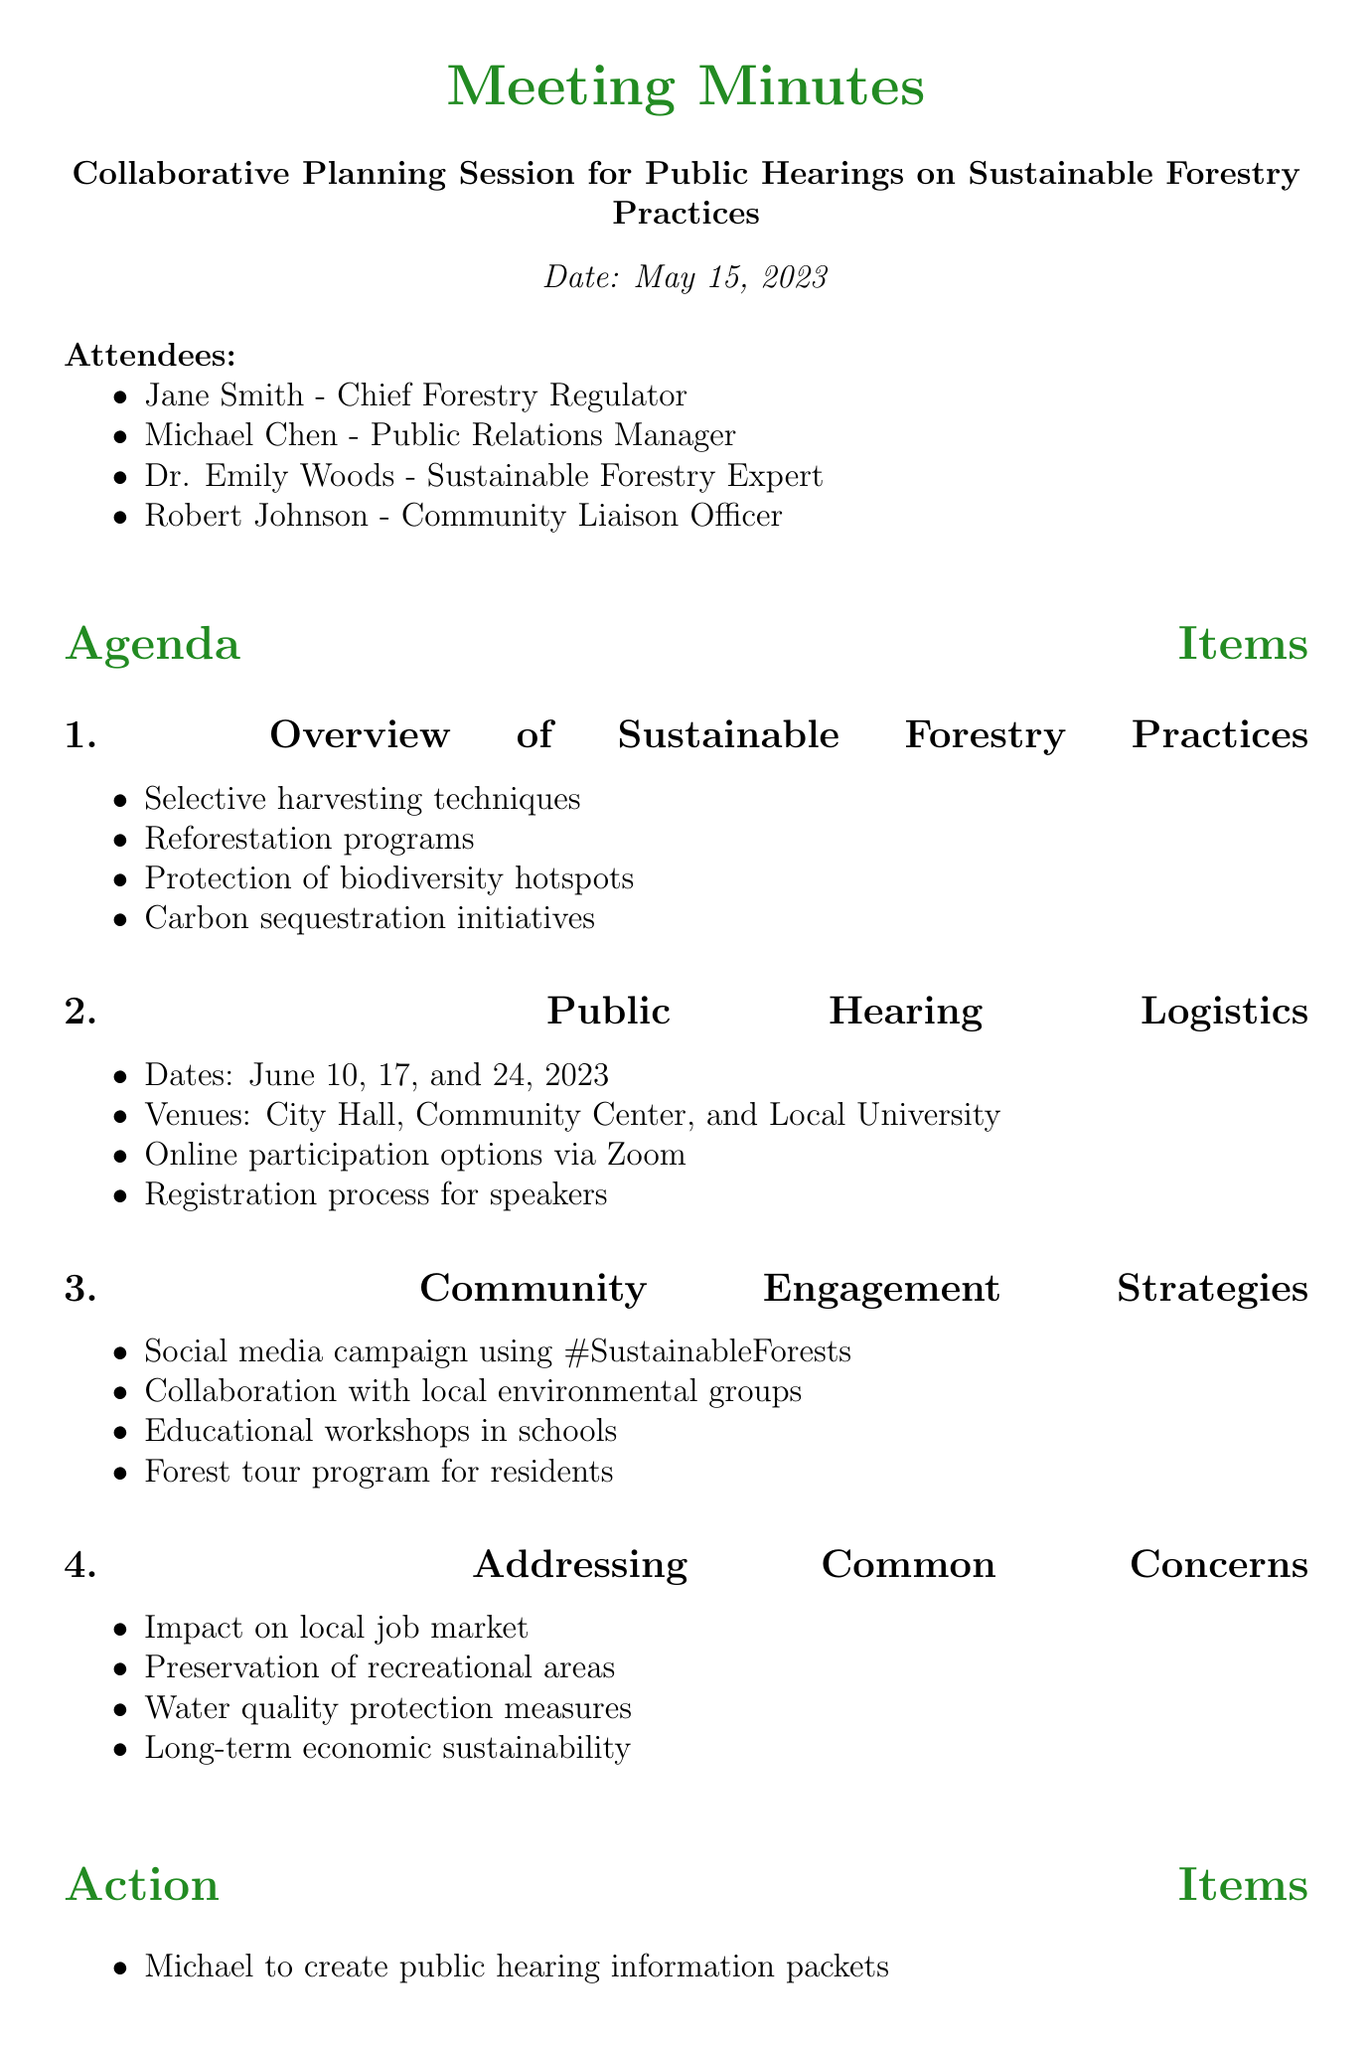What is the meeting title? The meeting title is clearly stated at the top of the document.
Answer: Collaborative Planning Session for Public Hearings on Sustainable Forestry Practices Who is the Chief Forestry Regulator? The document lists attendees along with their titles, making it easy to find who holds which position.
Answer: Jane Smith What are the dates for the public hearings? The specific dates are listed under the Public Hearing Logistics agenda item in the document.
Answer: June 10, 17, and 24, 2023 What is one of the community engagement strategies mentioned? The document provides a list of strategies under the Community Engagement Strategies section, allowing for easy retrieval of information.
Answer: Social media campaign using #SustainableForests How many action items are listed? The count of action items can be derived from the number of entries under the Action Items section.
Answer: Four What concern is addressed related to local job market? The document lists common concerns and one specifically addresses the local job market.
Answer: Impact on local job market Who is responsible for preparing the presentation on sustainable forestry practices? Each action item specifies who is responsible for completing each task.
Answer: Emily What is the date for the next meeting? The date for the next meeting is stated at the end of the meeting minutes.
Answer: May 29, 2023 